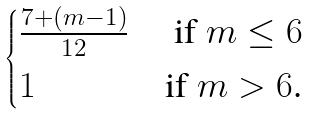<formula> <loc_0><loc_0><loc_500><loc_500>\begin{cases} \frac { 7 + ( m - 1 ) } { 1 2 } & \text { if $m\leq   6$} \\ 1 & \text {if $m > 6$.} \end{cases}</formula> 